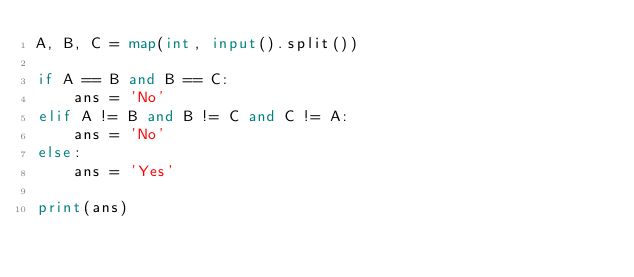Convert code to text. <code><loc_0><loc_0><loc_500><loc_500><_Python_>A, B, C = map(int, input().split())

if A == B and B == C:
    ans = 'No'
elif A != B and B != C and C != A:
    ans = 'No'
else:
    ans = 'Yes'

print(ans)
</code> 